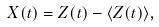<formula> <loc_0><loc_0><loc_500><loc_500>X ( t ) = Z ( t ) - \langle Z ( t ) \rangle ,</formula> 